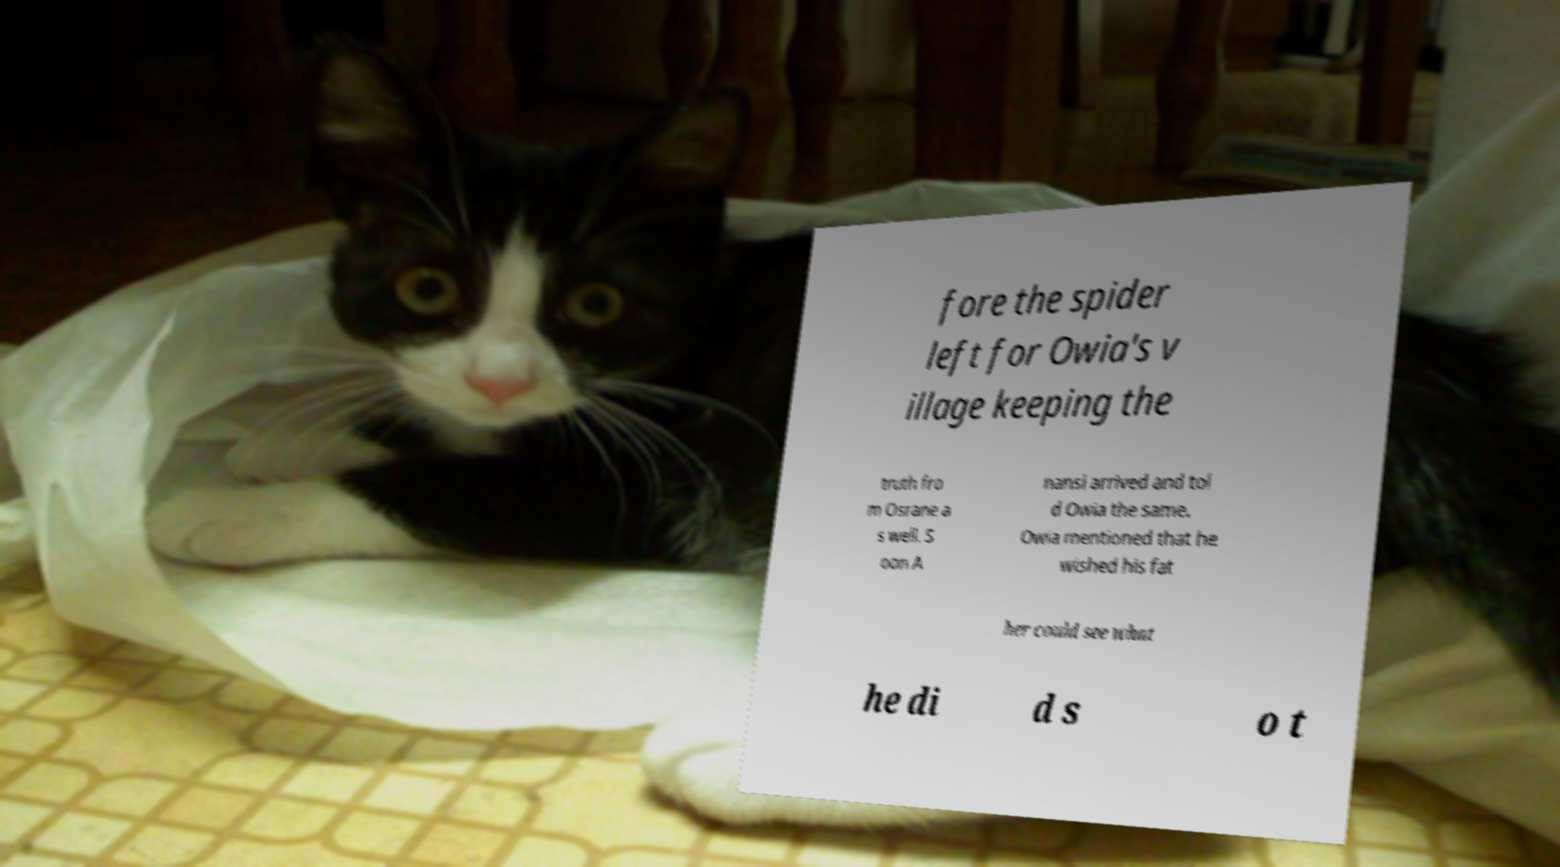Please read and relay the text visible in this image. What does it say? fore the spider left for Owia's v illage keeping the truth fro m Osrane a s well. S oon A nansi arrived and tol d Owia the same. Owia mentioned that he wished his fat her could see what he di d s o t 